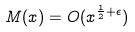Convert formula to latex. <formula><loc_0><loc_0><loc_500><loc_500>M ( x ) = O ( x ^ { \frac { 1 } { 2 } + \epsilon } )</formula> 